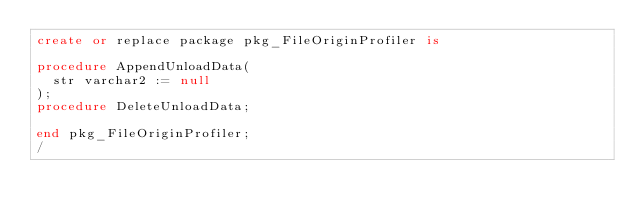<code> <loc_0><loc_0><loc_500><loc_500><_SQL_>create or replace package pkg_FileOriginProfiler is

procedure AppendUnloadData(
  str varchar2 := null
);
procedure DeleteUnloadData;

end pkg_FileOriginProfiler;
/
</code> 